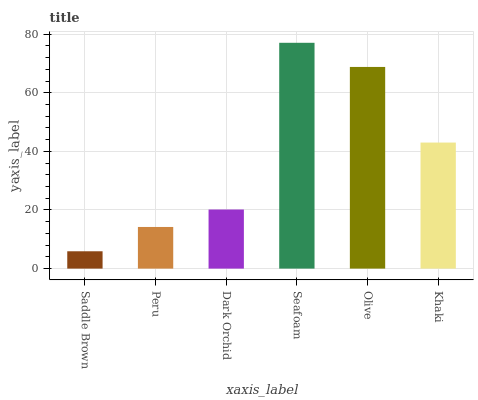Is Saddle Brown the minimum?
Answer yes or no. Yes. Is Seafoam the maximum?
Answer yes or no. Yes. Is Peru the minimum?
Answer yes or no. No. Is Peru the maximum?
Answer yes or no. No. Is Peru greater than Saddle Brown?
Answer yes or no. Yes. Is Saddle Brown less than Peru?
Answer yes or no. Yes. Is Saddle Brown greater than Peru?
Answer yes or no. No. Is Peru less than Saddle Brown?
Answer yes or no. No. Is Khaki the high median?
Answer yes or no. Yes. Is Dark Orchid the low median?
Answer yes or no. Yes. Is Seafoam the high median?
Answer yes or no. No. Is Saddle Brown the low median?
Answer yes or no. No. 